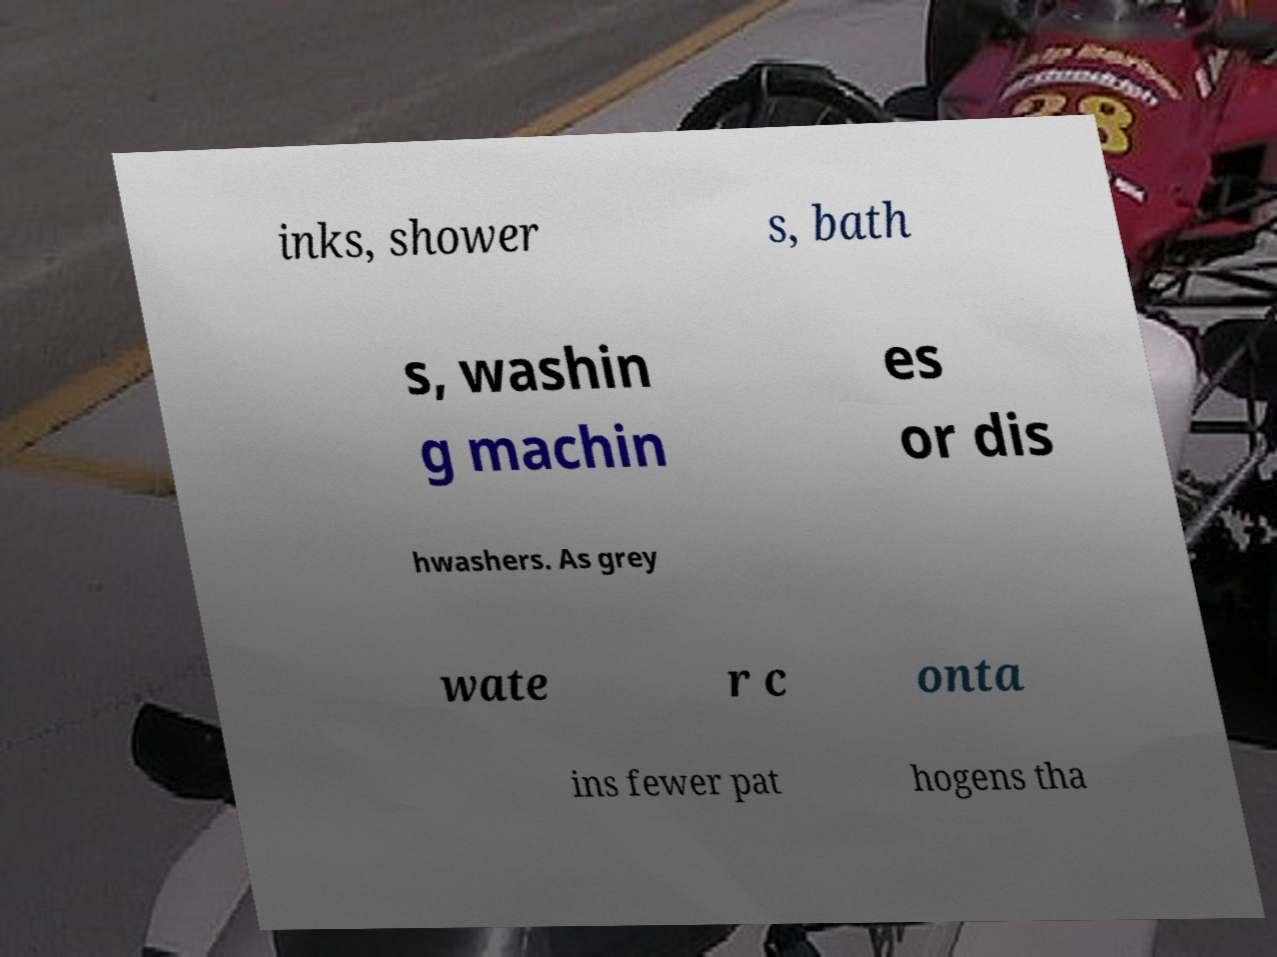Could you extract and type out the text from this image? inks, shower s, bath s, washin g machin es or dis hwashers. As grey wate r c onta ins fewer pat hogens tha 